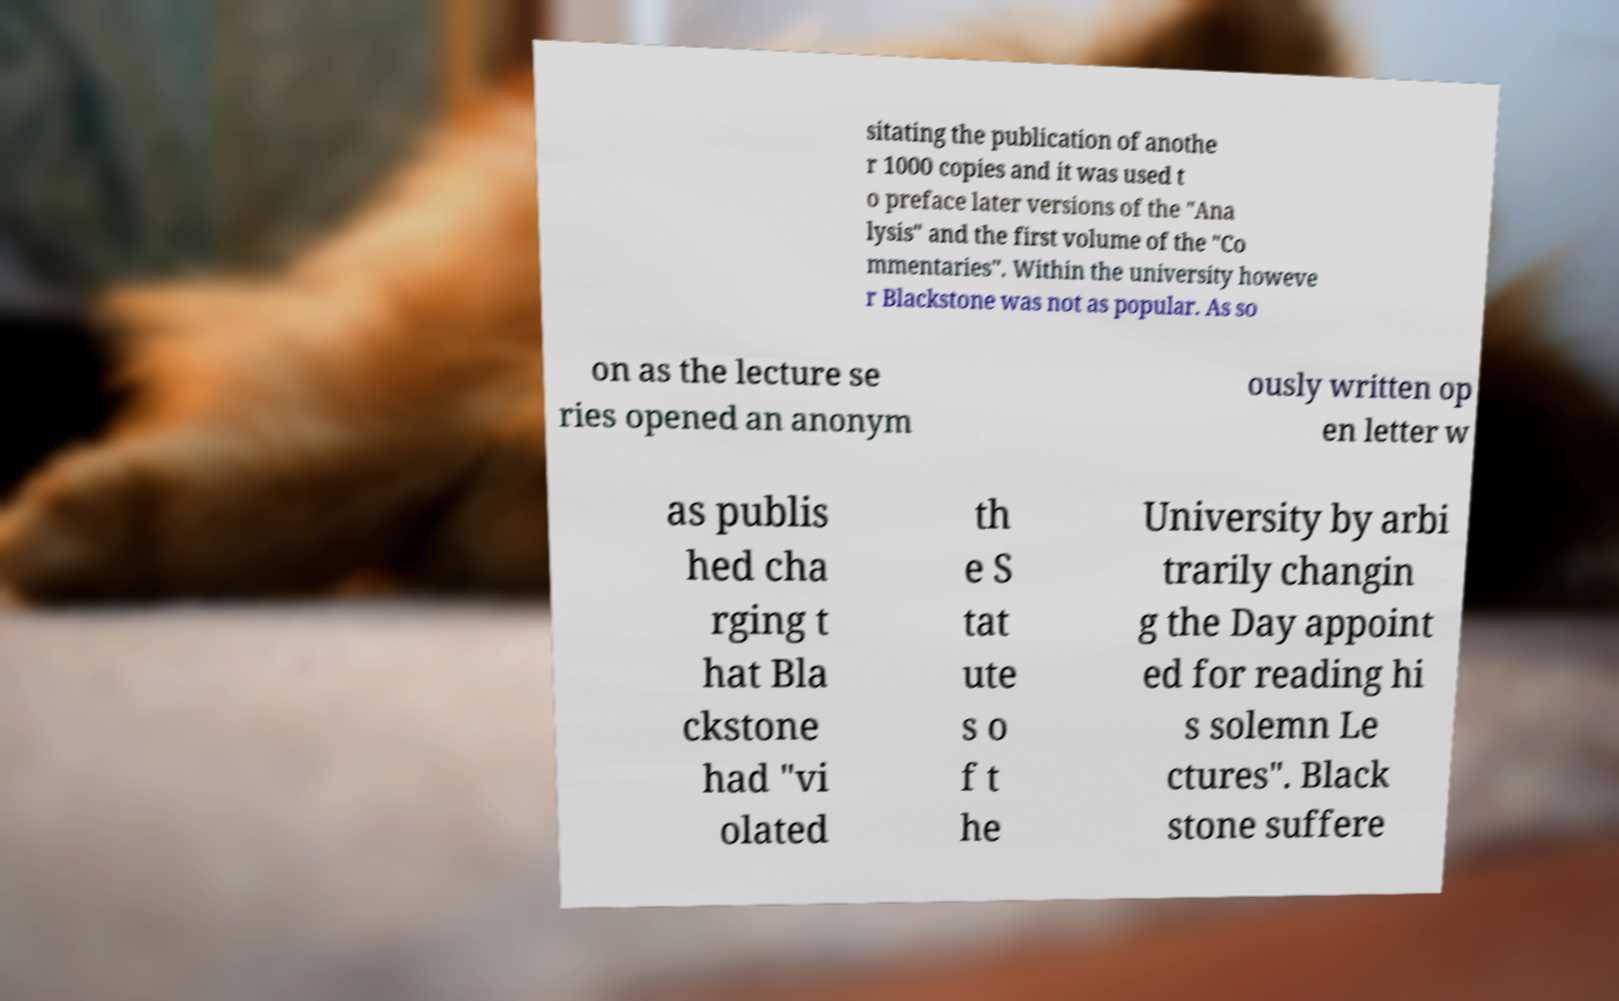For documentation purposes, I need the text within this image transcribed. Could you provide that? sitating the publication of anothe r 1000 copies and it was used t o preface later versions of the "Ana lysis" and the first volume of the "Co mmentaries". Within the university howeve r Blackstone was not as popular. As so on as the lecture se ries opened an anonym ously written op en letter w as publis hed cha rging t hat Bla ckstone had "vi olated th e S tat ute s o f t he University by arbi trarily changin g the Day appoint ed for reading hi s solemn Le ctures". Black stone suffere 